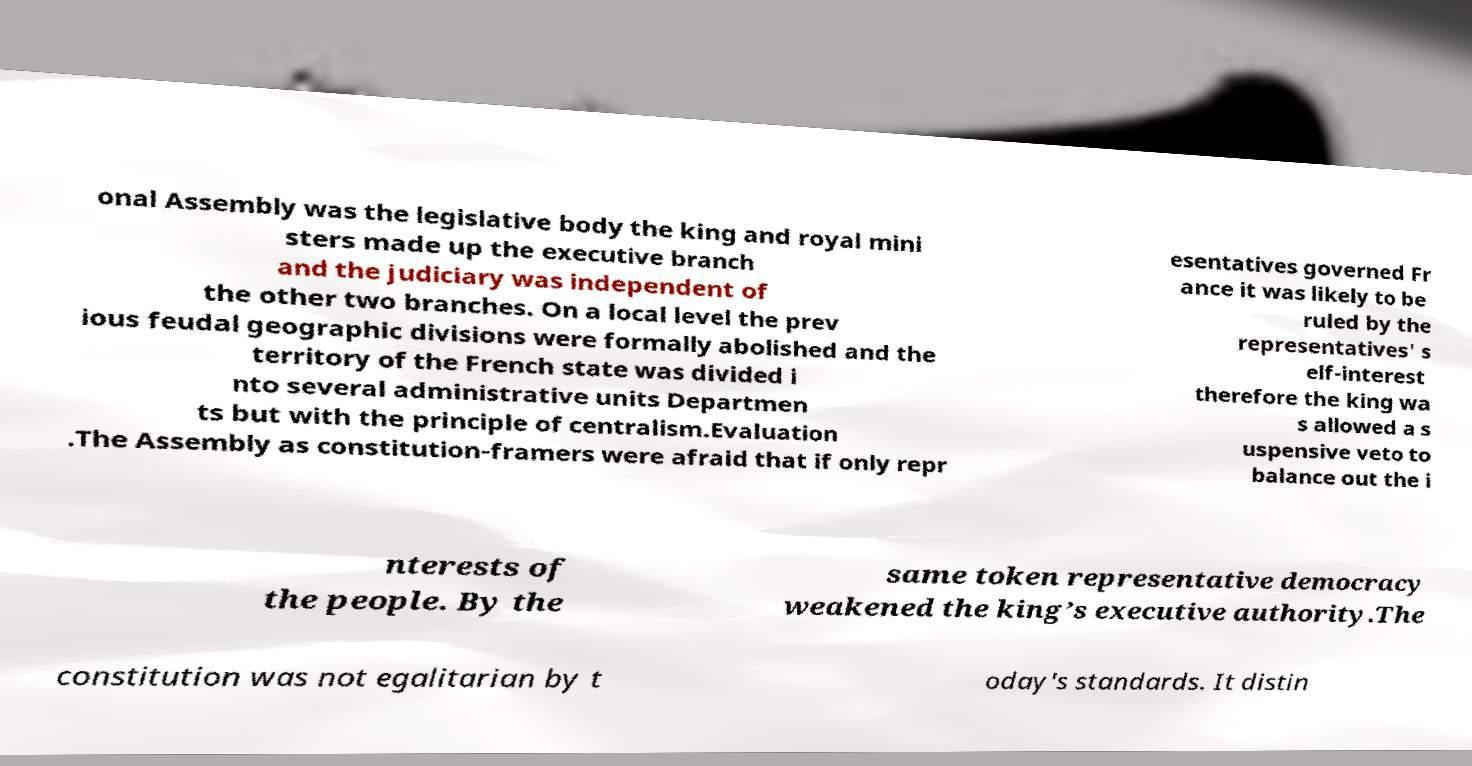Can you accurately transcribe the text from the provided image for me? onal Assembly was the legislative body the king and royal mini sters made up the executive branch and the judiciary was independent of the other two branches. On a local level the prev ious feudal geographic divisions were formally abolished and the territory of the French state was divided i nto several administrative units Departmen ts but with the principle of centralism.Evaluation .The Assembly as constitution-framers were afraid that if only repr esentatives governed Fr ance it was likely to be ruled by the representatives' s elf-interest therefore the king wa s allowed a s uspensive veto to balance out the i nterests of the people. By the same token representative democracy weakened the king’s executive authority.The constitution was not egalitarian by t oday's standards. It distin 